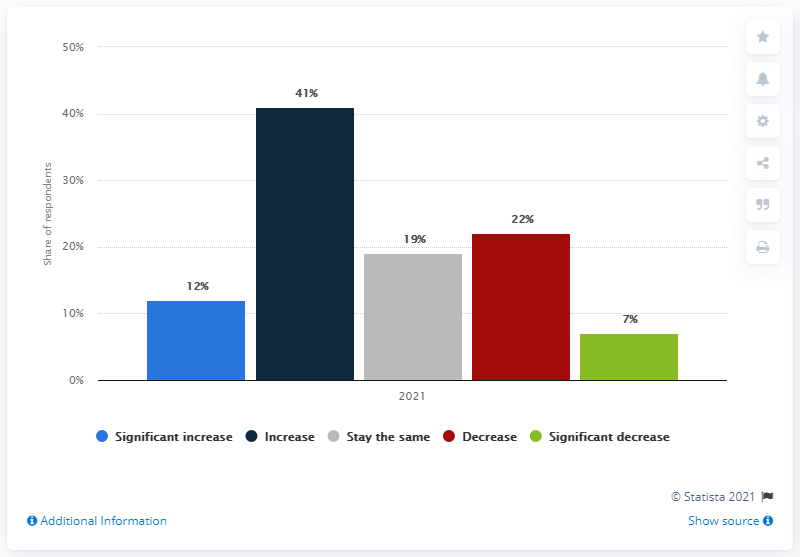Highlight a few significant elements in this photo. In the year 2021, Asian and Pacific countries witnessed a significant change in cross-border capital invested in European real estate markets. 